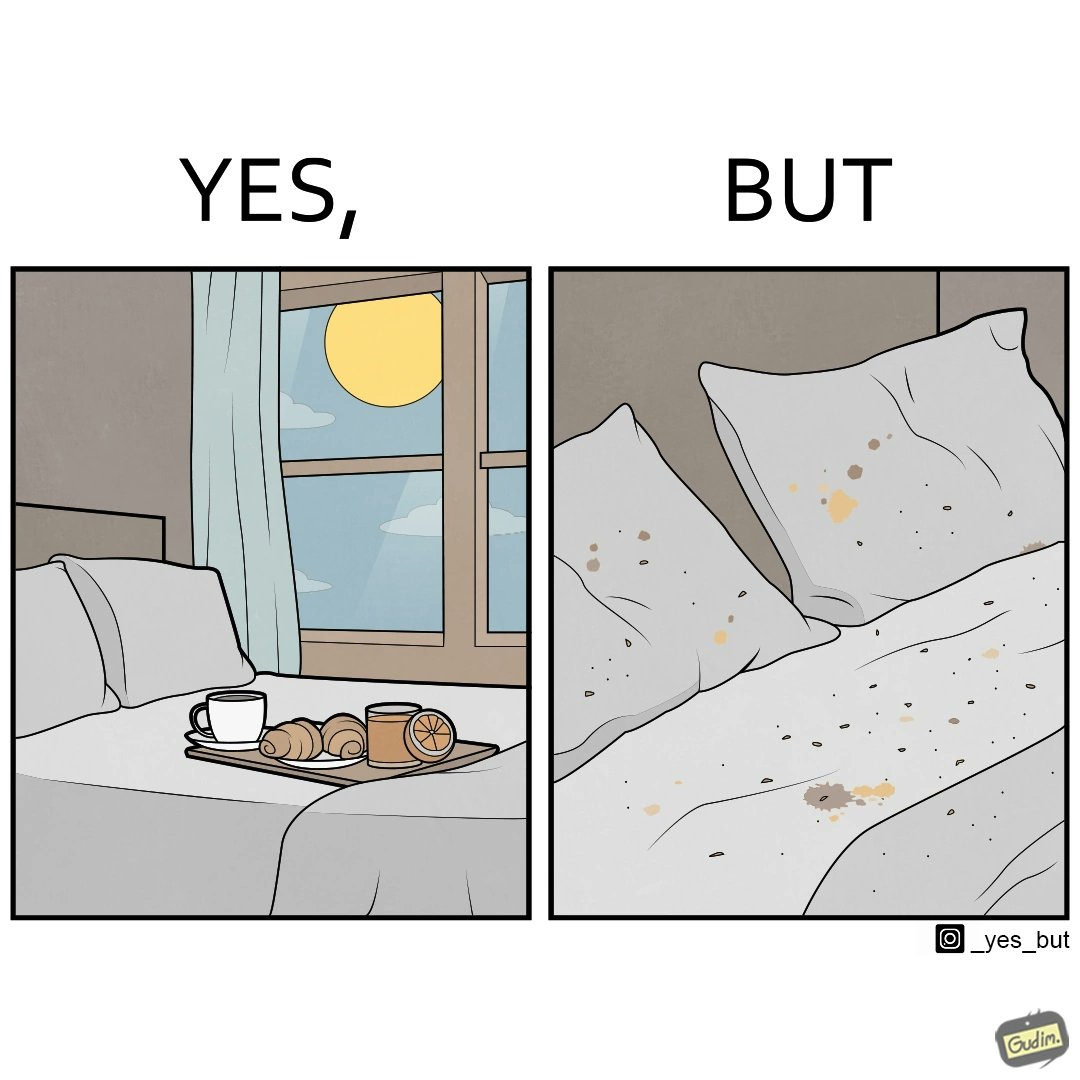Describe what you see in this image. The image is ironical, as having breakfast in bed is a luxury. However, eating while in bed leads to food crumbs, making the bed dirty, along with the need to clean the bed afterwards. 